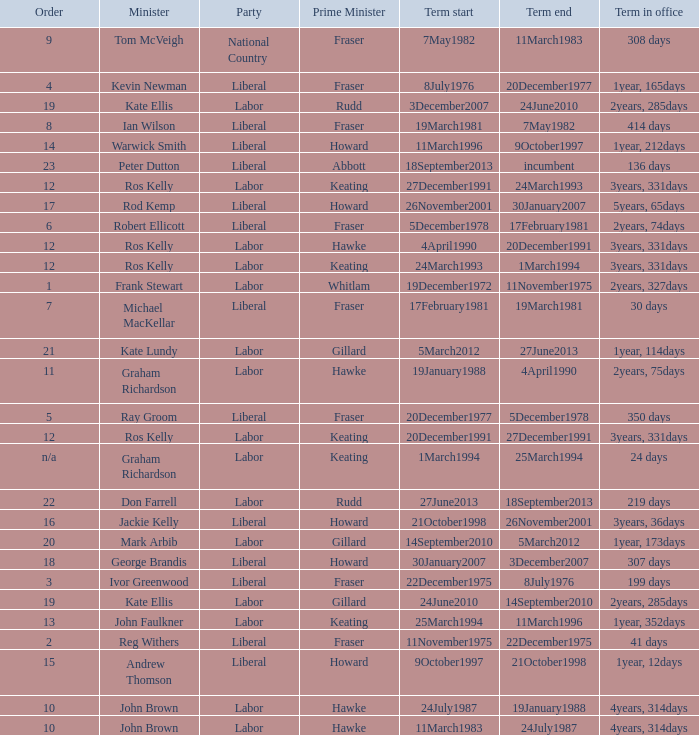Would you mind parsing the complete table? {'header': ['Order', 'Minister', 'Party', 'Prime Minister', 'Term start', 'Term end', 'Term in office'], 'rows': [['9', 'Tom McVeigh', 'National Country', 'Fraser', '7May1982', '11March1983', '308 days'], ['4', 'Kevin Newman', 'Liberal', 'Fraser', '8July1976', '20December1977', '1year, 165days'], ['19', 'Kate Ellis', 'Labor', 'Rudd', '3December2007', '24June2010', '2years, 285days'], ['8', 'Ian Wilson', 'Liberal', 'Fraser', '19March1981', '7May1982', '414 days'], ['14', 'Warwick Smith', 'Liberal', 'Howard', '11March1996', '9October1997', '1year, 212days'], ['23', 'Peter Dutton', 'Liberal', 'Abbott', '18September2013', 'incumbent', '136 days'], ['12', 'Ros Kelly', 'Labor', 'Keating', '27December1991', '24March1993', '3years, 331days'], ['17', 'Rod Kemp', 'Liberal', 'Howard', '26November2001', '30January2007', '5years, 65days'], ['6', 'Robert Ellicott', 'Liberal', 'Fraser', '5December1978', '17February1981', '2years, 74days'], ['12', 'Ros Kelly', 'Labor', 'Hawke', '4April1990', '20December1991', '3years, 331days'], ['12', 'Ros Kelly', 'Labor', 'Keating', '24March1993', '1March1994', '3years, 331days'], ['1', 'Frank Stewart', 'Labor', 'Whitlam', '19December1972', '11November1975', '2years, 327days'], ['7', 'Michael MacKellar', 'Liberal', 'Fraser', '17February1981', '19March1981', '30 days'], ['21', 'Kate Lundy', 'Labor', 'Gillard', '5March2012', '27June2013', '1year, 114days'], ['11', 'Graham Richardson', 'Labor', 'Hawke', '19January1988', '4April1990', '2years, 75days'], ['5', 'Ray Groom', 'Liberal', 'Fraser', '20December1977', '5December1978', '350 days'], ['12', 'Ros Kelly', 'Labor', 'Keating', '20December1991', '27December1991', '3years, 331days'], ['n/a', 'Graham Richardson', 'Labor', 'Keating', '1March1994', '25March1994', '24 days'], ['22', 'Don Farrell', 'Labor', 'Rudd', '27June2013', '18September2013', '219 days'], ['16', 'Jackie Kelly', 'Liberal', 'Howard', '21October1998', '26November2001', '3years, 36days'], ['20', 'Mark Arbib', 'Labor', 'Gillard', '14September2010', '5March2012', '1year, 173days'], ['18', 'George Brandis', 'Liberal', 'Howard', '30January2007', '3December2007', '307 days'], ['3', 'Ivor Greenwood', 'Liberal', 'Fraser', '22December1975', '8July1976', '199 days'], ['19', 'Kate Ellis', 'Labor', 'Gillard', '24June2010', '14September2010', '2years, 285days'], ['13', 'John Faulkner', 'Labor', 'Keating', '25March1994', '11March1996', '1year, 352days'], ['2', 'Reg Withers', 'Liberal', 'Fraser', '11November1975', '22December1975', '41 days'], ['15', 'Andrew Thomson', 'Liberal', 'Howard', '9October1997', '21October1998', '1year, 12days'], ['10', 'John Brown', 'Labor', 'Hawke', '24July1987', '19January1988', '4years, 314days'], ['10', 'John Brown', 'Labor', 'Hawke', '11March1983', '24July1987', '4years, 314days']]} What is the Term in office with an Order that is 9? 308 days. 